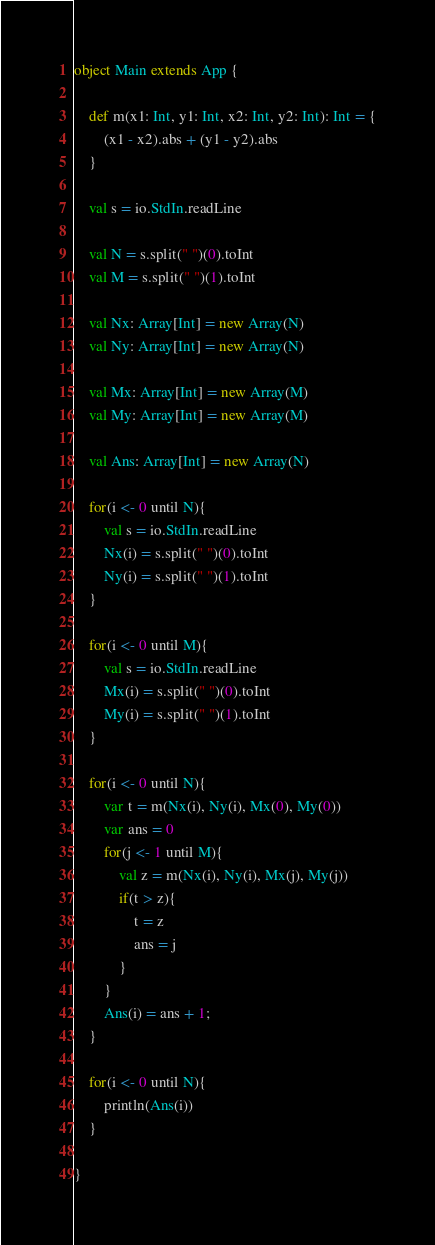Convert code to text. <code><loc_0><loc_0><loc_500><loc_500><_Scala_>
object Main extends App {

	def m(x1: Int, y1: Int, x2: Int, y2: Int): Int = {
		(x1 - x2).abs + (y1 - y2).abs
	}

	val s = io.StdIn.readLine

	val N = s.split(" ")(0).toInt
	val M = s.split(" ")(1).toInt

	val Nx: Array[Int] = new Array(N)
	val Ny: Array[Int] = new Array(N)

	val Mx: Array[Int] = new Array(M)
	val My: Array[Int] = new Array(M)

	val Ans: Array[Int] = new Array(N)

	for(i <- 0 until N){
		val s = io.StdIn.readLine
		Nx(i) = s.split(" ")(0).toInt
		Ny(i) = s.split(" ")(1).toInt
	}

	for(i <- 0 until M){
		val s = io.StdIn.readLine
		Mx(i) = s.split(" ")(0).toInt
		My(i) = s.split(" ")(1).toInt
	}

	for(i <- 0 until N){
		var t = m(Nx(i), Ny(i), Mx(0), My(0))
		var ans = 0
		for(j <- 1 until M){
			val z = m(Nx(i), Ny(i), Mx(j), My(j)) 
			if(t > z){
				t = z
				ans = j
			}
		}
		Ans(i) = ans + 1;
	}

	for(i <- 0 until N){
		println(Ans(i))
	}

}</code> 